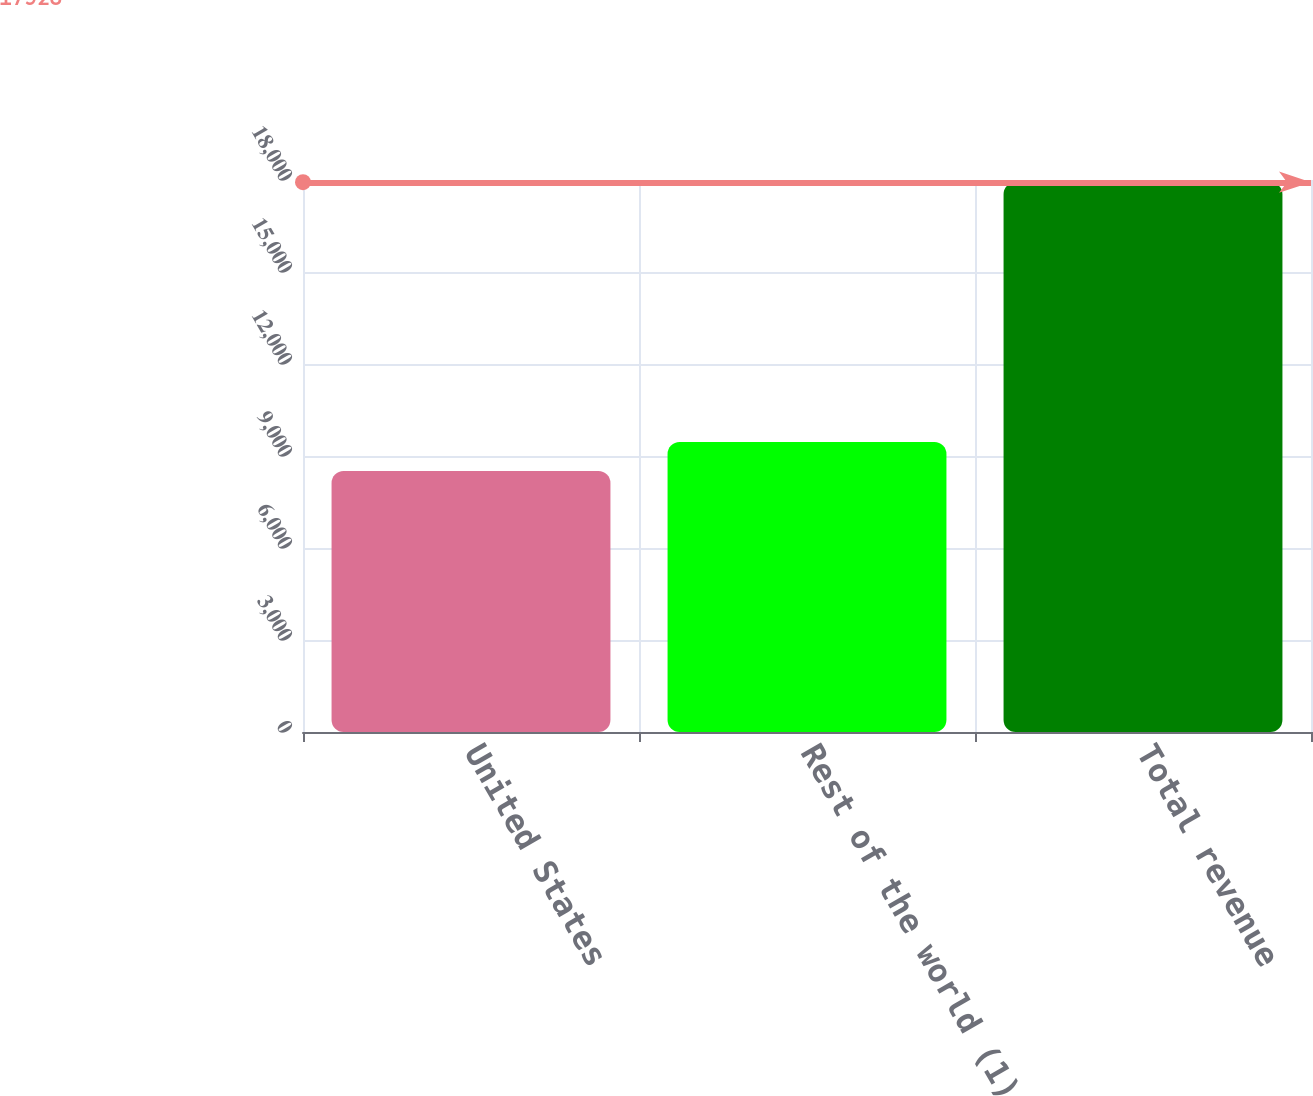<chart> <loc_0><loc_0><loc_500><loc_500><bar_chart><fcel>United States<fcel>Rest of the world (1)<fcel>Total revenue<nl><fcel>8513<fcel>9454.5<fcel>17928<nl></chart> 